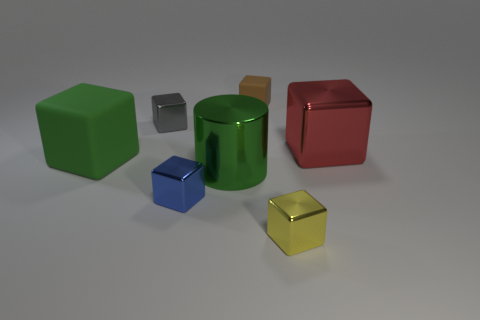What is the shape of the other shiny thing that is the same size as the red thing?
Your answer should be compact. Cylinder. Is there anything else that is the same size as the green shiny thing?
Your response must be concise. Yes. What is the material of the big block that is on the right side of the large shiny object to the left of the small brown rubber cube?
Your answer should be very brief. Metal. Is the metal cylinder the same size as the yellow metal block?
Offer a terse response. No. What number of things are either things that are to the left of the small rubber block or small green shiny things?
Offer a terse response. 4. What shape is the green thing that is on the left side of the big green metal cylinder that is in front of the small gray metal block?
Keep it short and to the point. Cube. Do the yellow metallic thing and the green object that is on the left side of the tiny blue metal block have the same size?
Provide a short and direct response. No. What material is the green object that is on the right side of the blue object?
Make the answer very short. Metal. What number of small blocks are both in front of the tiny rubber object and behind the tiny blue cube?
Provide a succinct answer. 1. What material is the blue cube that is the same size as the gray thing?
Your response must be concise. Metal. 